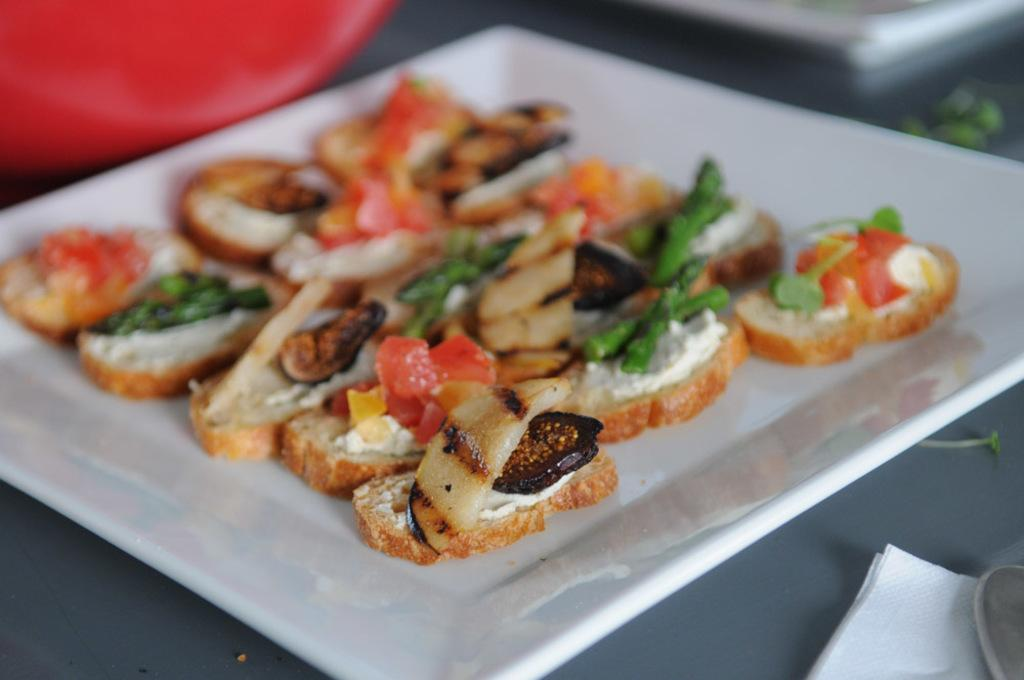What type of furniture is in the image? There is a table in the image. What is placed on the table? A saucer and tissue paper are present on the table. What else can be seen on the table? There are other objects on the table. What is on the saucer? Food items are visible on the saucer. What type of vacation is being planned on the table in the image? There is no indication of a vacation being planned in the image; it only shows a table with various objects on it. 